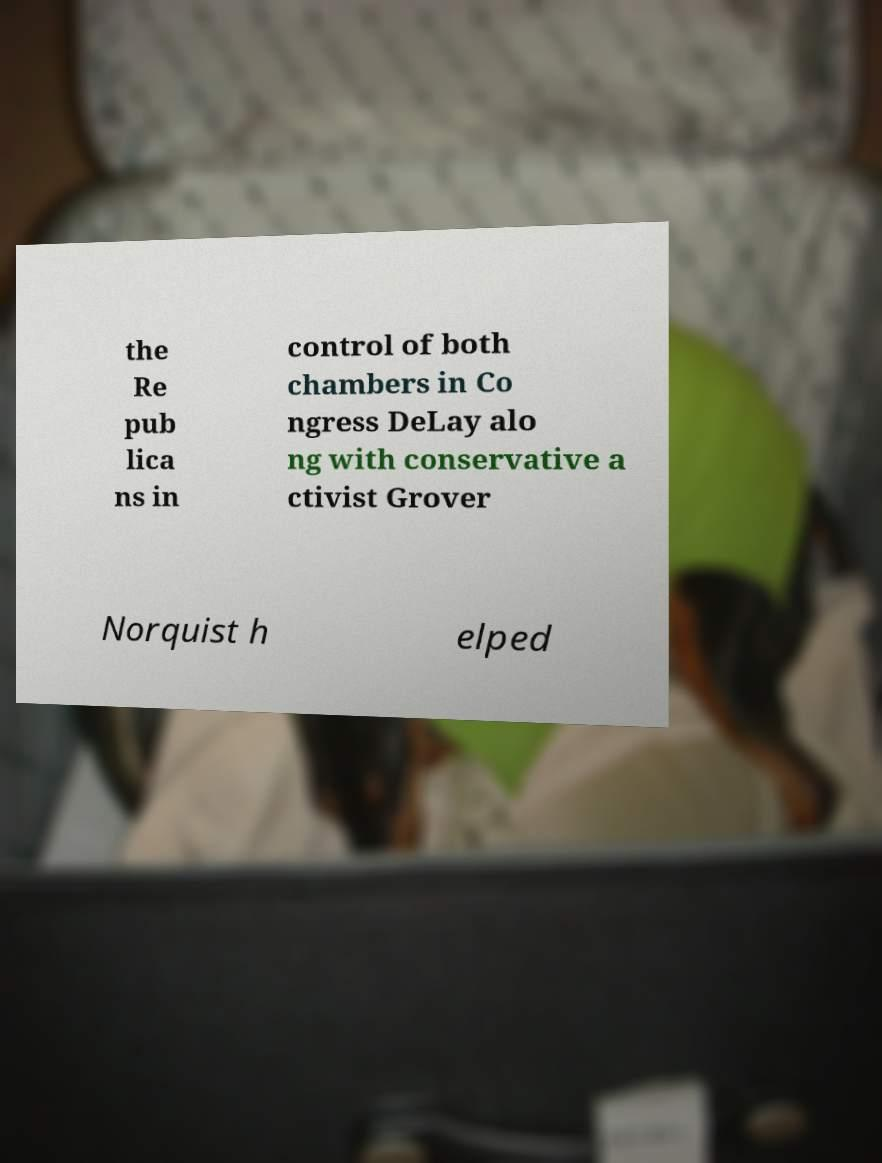Please read and relay the text visible in this image. What does it say? the Re pub lica ns in control of both chambers in Co ngress DeLay alo ng with conservative a ctivist Grover Norquist h elped 